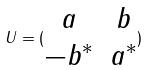<formula> <loc_0><loc_0><loc_500><loc_500>U = ( \begin{matrix} a & b \\ - b ^ { * } & a ^ { * } \\ \end{matrix} )</formula> 